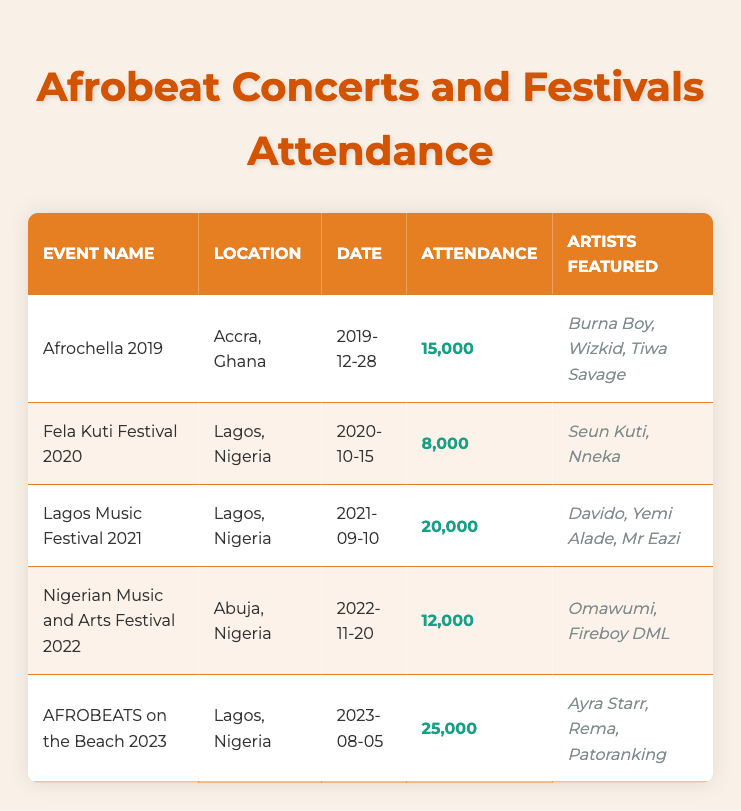What was the attendance at Afrochella 2019? The table lists Afrochella 2019 with an attendance of 15,000. Therefore, I can simply refer to the corresponding row to find this information.
Answer: 15,000 How many artists were featured in the Lagos Music Festival 2021? Referring to the row for the Lagos Music Festival 2021, it shows that three artists were featured: Davido, Yemi Alade, and Mr Eazi.
Answer: 3 What is the difference in attendance between AFROBEATS on the Beach 2023 and Fela Kuti Festival 2020? To find the difference, I take the attendance of AFROBEATS on the Beach 2023, which is 25,000, and subtract the attendance of Fela Kuti Festival 2020, which is 8,000. Thus, 25,000 - 8,000 = 17,000.
Answer: 17,000 Is the attendance at the Nigerian Music and Arts Festival 2022 greater than 15,000? The table indicates that the attendance for the Nigerian Music and Arts Festival 2022 is 12,000, which is less than 15,000. Therefore, the answer to this question is no.
Answer: No What is the average attendance of the concerts and festivals from 2019 to 2023? To calculate the average, I first sum the attendance figures: 15,000 (Afrochella 2019) + 8,000 (Fela Kuti Festival 2020) + 20,000 (Lagos Music Festival 2021) + 12,000 (Nigerian Music and Arts Festival 2022) + 25,000 (AFROBEATS on the Beach 2023) = 80,000. Then I divide by the number of events, which is 5: 80,000 / 5 = 16,000.
Answer: 16,000 Which event had the highest attendance? By comparing the attendance figures across all events, AFROBEATS on the Beach 2023 has the highest attendance at 25,000, surpassing all other events listed in the table.
Answer: AFROBEATS on the Beach 2023 